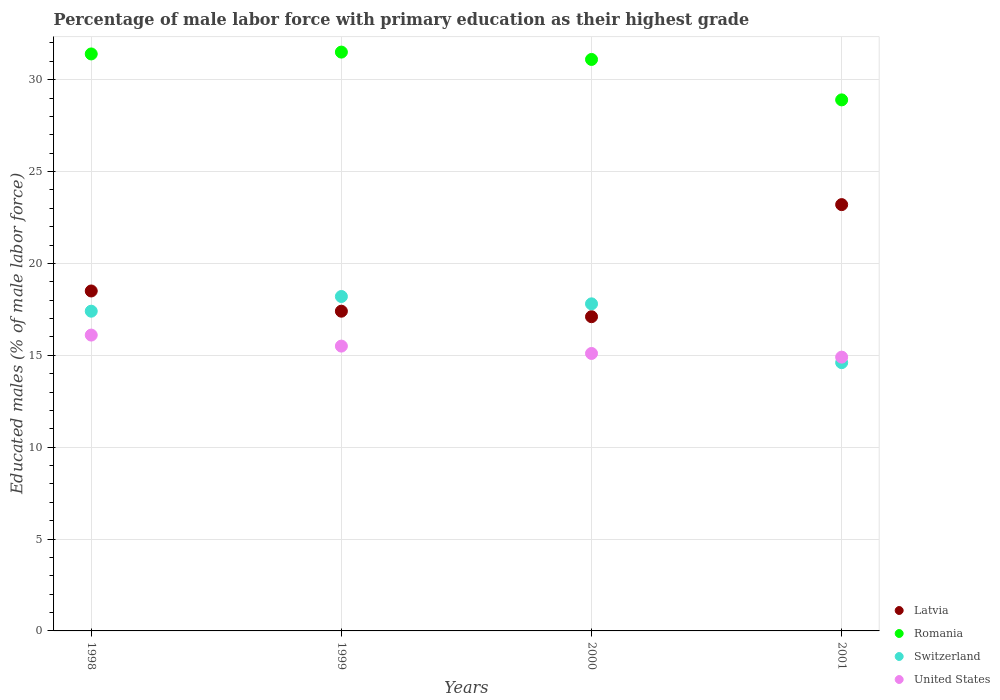How many different coloured dotlines are there?
Offer a very short reply. 4. What is the percentage of male labor force with primary education in United States in 1999?
Offer a terse response. 15.5. Across all years, what is the maximum percentage of male labor force with primary education in Romania?
Ensure brevity in your answer.  31.5. Across all years, what is the minimum percentage of male labor force with primary education in Latvia?
Provide a short and direct response. 17.1. In which year was the percentage of male labor force with primary education in Latvia maximum?
Ensure brevity in your answer.  2001. In which year was the percentage of male labor force with primary education in Romania minimum?
Your response must be concise. 2001. What is the total percentage of male labor force with primary education in Romania in the graph?
Your answer should be compact. 122.9. What is the difference between the percentage of male labor force with primary education in Latvia in 1998 and that in 1999?
Give a very brief answer. 1.1. What is the difference between the percentage of male labor force with primary education in United States in 1998 and the percentage of male labor force with primary education in Romania in 1999?
Your answer should be compact. -15.4. What is the average percentage of male labor force with primary education in United States per year?
Offer a terse response. 15.4. In the year 2000, what is the difference between the percentage of male labor force with primary education in Switzerland and percentage of male labor force with primary education in United States?
Keep it short and to the point. 2.7. What is the ratio of the percentage of male labor force with primary education in Romania in 1998 to that in 2000?
Your response must be concise. 1.01. Is the difference between the percentage of male labor force with primary education in Switzerland in 1999 and 2000 greater than the difference between the percentage of male labor force with primary education in United States in 1999 and 2000?
Provide a succinct answer. Yes. What is the difference between the highest and the second highest percentage of male labor force with primary education in United States?
Offer a terse response. 0.6. What is the difference between the highest and the lowest percentage of male labor force with primary education in Latvia?
Provide a succinct answer. 6.1. Is it the case that in every year, the sum of the percentage of male labor force with primary education in Switzerland and percentage of male labor force with primary education in United States  is greater than the sum of percentage of male labor force with primary education in Latvia and percentage of male labor force with primary education in Romania?
Offer a terse response. No. Is the percentage of male labor force with primary education in Latvia strictly greater than the percentage of male labor force with primary education in Switzerland over the years?
Give a very brief answer. No. Is the percentage of male labor force with primary education in Latvia strictly less than the percentage of male labor force with primary education in Switzerland over the years?
Make the answer very short. No. What is the difference between two consecutive major ticks on the Y-axis?
Your response must be concise. 5. Does the graph contain grids?
Make the answer very short. Yes. What is the title of the graph?
Keep it short and to the point. Percentage of male labor force with primary education as their highest grade. Does "Tajikistan" appear as one of the legend labels in the graph?
Your response must be concise. No. What is the label or title of the X-axis?
Offer a terse response. Years. What is the label or title of the Y-axis?
Ensure brevity in your answer.  Educated males (% of male labor force). What is the Educated males (% of male labor force) of Latvia in 1998?
Offer a very short reply. 18.5. What is the Educated males (% of male labor force) of Romania in 1998?
Provide a succinct answer. 31.4. What is the Educated males (% of male labor force) of Switzerland in 1998?
Your answer should be very brief. 17.4. What is the Educated males (% of male labor force) of United States in 1998?
Offer a very short reply. 16.1. What is the Educated males (% of male labor force) of Latvia in 1999?
Keep it short and to the point. 17.4. What is the Educated males (% of male labor force) of Romania in 1999?
Your response must be concise. 31.5. What is the Educated males (% of male labor force) of Switzerland in 1999?
Provide a succinct answer. 18.2. What is the Educated males (% of male labor force) of United States in 1999?
Your answer should be very brief. 15.5. What is the Educated males (% of male labor force) in Latvia in 2000?
Make the answer very short. 17.1. What is the Educated males (% of male labor force) in Romania in 2000?
Provide a short and direct response. 31.1. What is the Educated males (% of male labor force) in Switzerland in 2000?
Provide a succinct answer. 17.8. What is the Educated males (% of male labor force) of United States in 2000?
Make the answer very short. 15.1. What is the Educated males (% of male labor force) of Latvia in 2001?
Keep it short and to the point. 23.2. What is the Educated males (% of male labor force) in Romania in 2001?
Provide a short and direct response. 28.9. What is the Educated males (% of male labor force) in Switzerland in 2001?
Make the answer very short. 14.6. What is the Educated males (% of male labor force) in United States in 2001?
Keep it short and to the point. 14.9. Across all years, what is the maximum Educated males (% of male labor force) in Latvia?
Your answer should be very brief. 23.2. Across all years, what is the maximum Educated males (% of male labor force) in Romania?
Keep it short and to the point. 31.5. Across all years, what is the maximum Educated males (% of male labor force) in Switzerland?
Provide a succinct answer. 18.2. Across all years, what is the maximum Educated males (% of male labor force) of United States?
Make the answer very short. 16.1. Across all years, what is the minimum Educated males (% of male labor force) in Latvia?
Ensure brevity in your answer.  17.1. Across all years, what is the minimum Educated males (% of male labor force) in Romania?
Your answer should be very brief. 28.9. Across all years, what is the minimum Educated males (% of male labor force) of Switzerland?
Keep it short and to the point. 14.6. Across all years, what is the minimum Educated males (% of male labor force) in United States?
Offer a terse response. 14.9. What is the total Educated males (% of male labor force) of Latvia in the graph?
Your answer should be compact. 76.2. What is the total Educated males (% of male labor force) of Romania in the graph?
Your response must be concise. 122.9. What is the total Educated males (% of male labor force) in United States in the graph?
Provide a short and direct response. 61.6. What is the difference between the Educated males (% of male labor force) in Latvia in 1998 and that in 1999?
Offer a very short reply. 1.1. What is the difference between the Educated males (% of male labor force) of Romania in 1998 and that in 1999?
Keep it short and to the point. -0.1. What is the difference between the Educated males (% of male labor force) of Switzerland in 1998 and that in 1999?
Offer a terse response. -0.8. What is the difference between the Educated males (% of male labor force) of United States in 1998 and that in 1999?
Your answer should be compact. 0.6. What is the difference between the Educated males (% of male labor force) in Latvia in 1998 and that in 2000?
Provide a succinct answer. 1.4. What is the difference between the Educated males (% of male labor force) in Romania in 1998 and that in 2000?
Keep it short and to the point. 0.3. What is the difference between the Educated males (% of male labor force) of Switzerland in 1998 and that in 2001?
Provide a succinct answer. 2.8. What is the difference between the Educated males (% of male labor force) of United States in 1998 and that in 2001?
Your response must be concise. 1.2. What is the difference between the Educated males (% of male labor force) in Latvia in 1999 and that in 2000?
Your answer should be very brief. 0.3. What is the difference between the Educated males (% of male labor force) of Romania in 1999 and that in 2000?
Your answer should be very brief. 0.4. What is the difference between the Educated males (% of male labor force) in Switzerland in 1999 and that in 2000?
Give a very brief answer. 0.4. What is the difference between the Educated males (% of male labor force) in United States in 1999 and that in 2000?
Provide a short and direct response. 0.4. What is the difference between the Educated males (% of male labor force) in Romania in 1999 and that in 2001?
Give a very brief answer. 2.6. What is the difference between the Educated males (% of male labor force) of United States in 1999 and that in 2001?
Provide a succinct answer. 0.6. What is the difference between the Educated males (% of male labor force) in Romania in 2000 and that in 2001?
Make the answer very short. 2.2. What is the difference between the Educated males (% of male labor force) in United States in 2000 and that in 2001?
Make the answer very short. 0.2. What is the difference between the Educated males (% of male labor force) in Latvia in 1998 and the Educated males (% of male labor force) in Switzerland in 1999?
Give a very brief answer. 0.3. What is the difference between the Educated males (% of male labor force) of Romania in 1998 and the Educated males (% of male labor force) of United States in 1999?
Keep it short and to the point. 15.9. What is the difference between the Educated males (% of male labor force) in Switzerland in 1998 and the Educated males (% of male labor force) in United States in 1999?
Provide a succinct answer. 1.9. What is the difference between the Educated males (% of male labor force) in Latvia in 1998 and the Educated males (% of male labor force) in Romania in 2000?
Ensure brevity in your answer.  -12.6. What is the difference between the Educated males (% of male labor force) in Latvia in 1998 and the Educated males (% of male labor force) in Switzerland in 2000?
Your answer should be compact. 0.7. What is the difference between the Educated males (% of male labor force) in Latvia in 1998 and the Educated males (% of male labor force) in Romania in 2001?
Offer a very short reply. -10.4. What is the difference between the Educated males (% of male labor force) in Latvia in 1999 and the Educated males (% of male labor force) in Romania in 2000?
Provide a succinct answer. -13.7. What is the difference between the Educated males (% of male labor force) of Latvia in 1999 and the Educated males (% of male labor force) of Switzerland in 2000?
Provide a succinct answer. -0.4. What is the difference between the Educated males (% of male labor force) in Switzerland in 1999 and the Educated males (% of male labor force) in United States in 2000?
Offer a very short reply. 3.1. What is the difference between the Educated males (% of male labor force) in Latvia in 1999 and the Educated males (% of male labor force) in United States in 2001?
Provide a short and direct response. 2.5. What is the difference between the Educated males (% of male labor force) of Romania in 1999 and the Educated males (% of male labor force) of Switzerland in 2001?
Your response must be concise. 16.9. What is the difference between the Educated males (% of male labor force) of Romania in 1999 and the Educated males (% of male labor force) of United States in 2001?
Give a very brief answer. 16.6. What is the difference between the Educated males (% of male labor force) in Latvia in 2000 and the Educated males (% of male labor force) in United States in 2001?
Your answer should be very brief. 2.2. What is the difference between the Educated males (% of male labor force) of Romania in 2000 and the Educated males (% of male labor force) of United States in 2001?
Keep it short and to the point. 16.2. What is the average Educated males (% of male labor force) in Latvia per year?
Make the answer very short. 19.05. What is the average Educated males (% of male labor force) of Romania per year?
Make the answer very short. 30.73. In the year 1998, what is the difference between the Educated males (% of male labor force) of Romania and Educated males (% of male labor force) of Switzerland?
Make the answer very short. 14. In the year 1998, what is the difference between the Educated males (% of male labor force) in Switzerland and Educated males (% of male labor force) in United States?
Your response must be concise. 1.3. In the year 1999, what is the difference between the Educated males (% of male labor force) of Latvia and Educated males (% of male labor force) of Romania?
Keep it short and to the point. -14.1. In the year 1999, what is the difference between the Educated males (% of male labor force) in Latvia and Educated males (% of male labor force) in Switzerland?
Your answer should be compact. -0.8. In the year 1999, what is the difference between the Educated males (% of male labor force) in Latvia and Educated males (% of male labor force) in United States?
Provide a short and direct response. 1.9. In the year 1999, what is the difference between the Educated males (% of male labor force) in Romania and Educated males (% of male labor force) in United States?
Give a very brief answer. 16. In the year 1999, what is the difference between the Educated males (% of male labor force) in Switzerland and Educated males (% of male labor force) in United States?
Make the answer very short. 2.7. In the year 2000, what is the difference between the Educated males (% of male labor force) in Latvia and Educated males (% of male labor force) in Romania?
Make the answer very short. -14. In the year 2000, what is the difference between the Educated males (% of male labor force) in Romania and Educated males (% of male labor force) in Switzerland?
Offer a very short reply. 13.3. In the year 2000, what is the difference between the Educated males (% of male labor force) in Switzerland and Educated males (% of male labor force) in United States?
Provide a short and direct response. 2.7. In the year 2001, what is the difference between the Educated males (% of male labor force) in Latvia and Educated males (% of male labor force) in Romania?
Ensure brevity in your answer.  -5.7. What is the ratio of the Educated males (% of male labor force) in Latvia in 1998 to that in 1999?
Your response must be concise. 1.06. What is the ratio of the Educated males (% of male labor force) of Switzerland in 1998 to that in 1999?
Your answer should be compact. 0.96. What is the ratio of the Educated males (% of male labor force) of United States in 1998 to that in 1999?
Provide a succinct answer. 1.04. What is the ratio of the Educated males (% of male labor force) of Latvia in 1998 to that in 2000?
Offer a terse response. 1.08. What is the ratio of the Educated males (% of male labor force) in Romania in 1998 to that in 2000?
Keep it short and to the point. 1.01. What is the ratio of the Educated males (% of male labor force) of Switzerland in 1998 to that in 2000?
Your answer should be very brief. 0.98. What is the ratio of the Educated males (% of male labor force) in United States in 1998 to that in 2000?
Provide a short and direct response. 1.07. What is the ratio of the Educated males (% of male labor force) of Latvia in 1998 to that in 2001?
Give a very brief answer. 0.8. What is the ratio of the Educated males (% of male labor force) in Romania in 1998 to that in 2001?
Your response must be concise. 1.09. What is the ratio of the Educated males (% of male labor force) of Switzerland in 1998 to that in 2001?
Provide a short and direct response. 1.19. What is the ratio of the Educated males (% of male labor force) in United States in 1998 to that in 2001?
Your answer should be very brief. 1.08. What is the ratio of the Educated males (% of male labor force) of Latvia in 1999 to that in 2000?
Ensure brevity in your answer.  1.02. What is the ratio of the Educated males (% of male labor force) in Romania in 1999 to that in 2000?
Provide a succinct answer. 1.01. What is the ratio of the Educated males (% of male labor force) in Switzerland in 1999 to that in 2000?
Your answer should be very brief. 1.02. What is the ratio of the Educated males (% of male labor force) of United States in 1999 to that in 2000?
Your answer should be compact. 1.03. What is the ratio of the Educated males (% of male labor force) in Latvia in 1999 to that in 2001?
Make the answer very short. 0.75. What is the ratio of the Educated males (% of male labor force) of Romania in 1999 to that in 2001?
Make the answer very short. 1.09. What is the ratio of the Educated males (% of male labor force) of Switzerland in 1999 to that in 2001?
Offer a terse response. 1.25. What is the ratio of the Educated males (% of male labor force) of United States in 1999 to that in 2001?
Provide a short and direct response. 1.04. What is the ratio of the Educated males (% of male labor force) of Latvia in 2000 to that in 2001?
Make the answer very short. 0.74. What is the ratio of the Educated males (% of male labor force) of Romania in 2000 to that in 2001?
Your answer should be very brief. 1.08. What is the ratio of the Educated males (% of male labor force) in Switzerland in 2000 to that in 2001?
Ensure brevity in your answer.  1.22. What is the ratio of the Educated males (% of male labor force) of United States in 2000 to that in 2001?
Make the answer very short. 1.01. What is the difference between the highest and the second highest Educated males (% of male labor force) in Latvia?
Keep it short and to the point. 4.7. What is the difference between the highest and the second highest Educated males (% of male labor force) of Switzerland?
Provide a succinct answer. 0.4. What is the difference between the highest and the lowest Educated males (% of male labor force) of Romania?
Your answer should be compact. 2.6. 